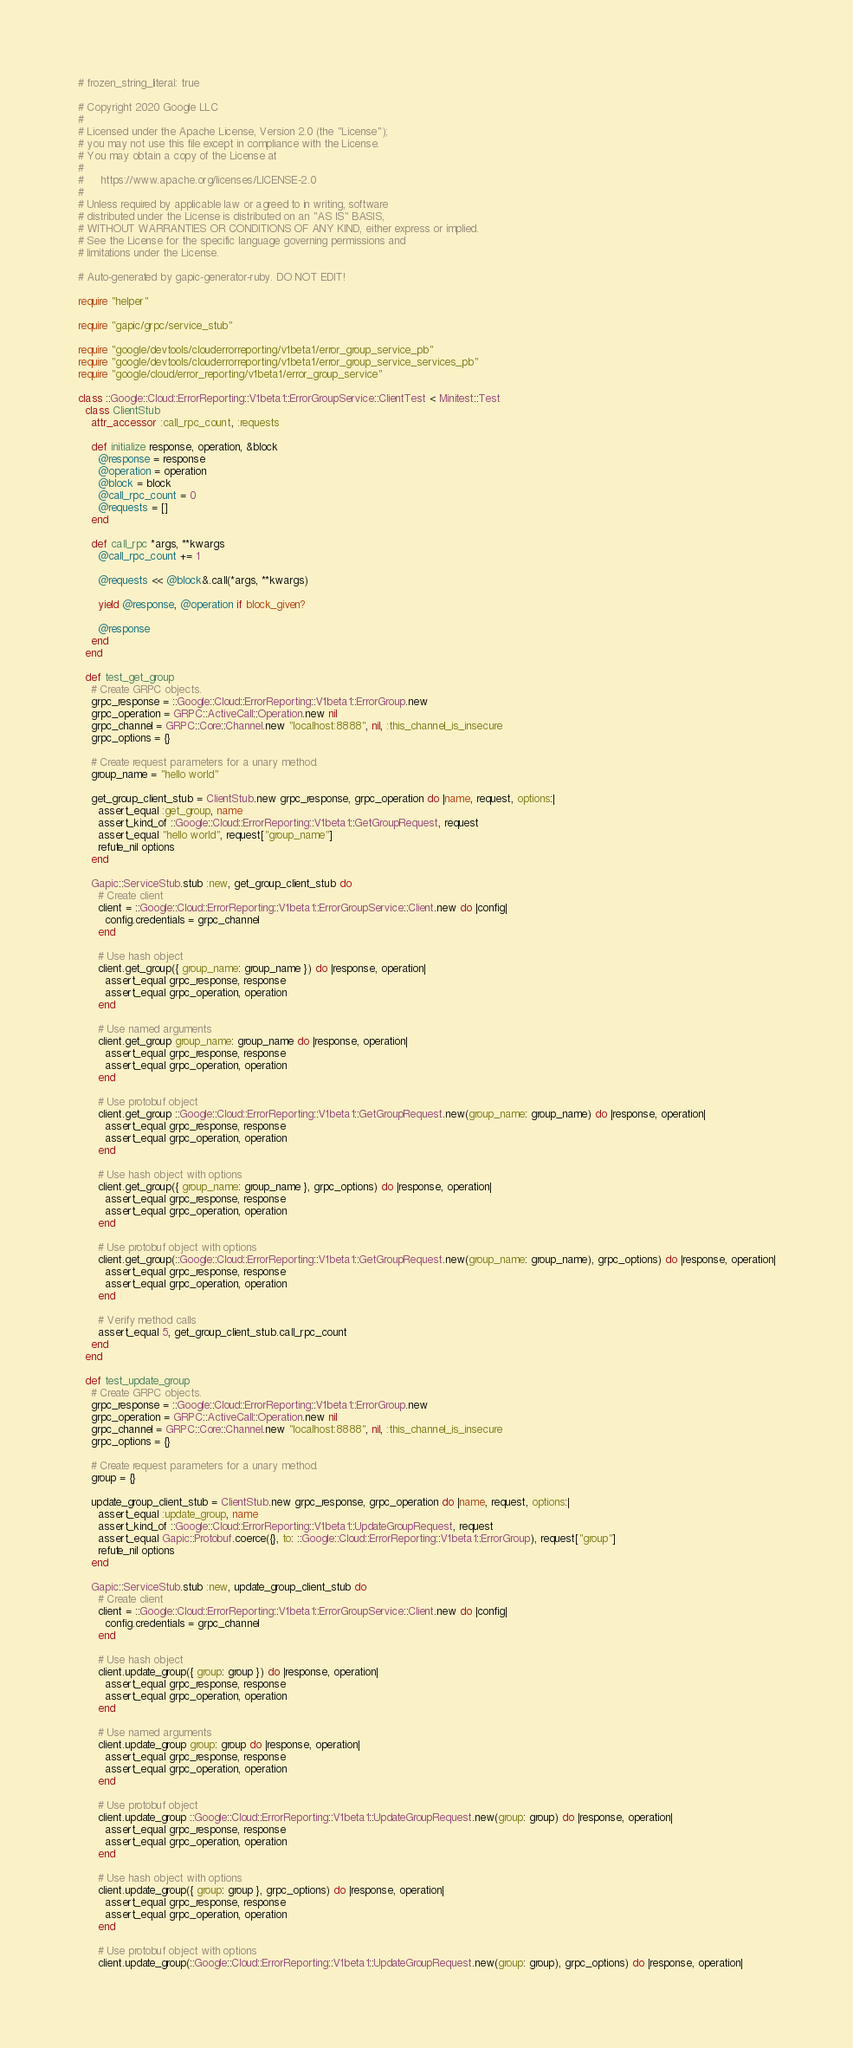<code> <loc_0><loc_0><loc_500><loc_500><_Ruby_># frozen_string_literal: true

# Copyright 2020 Google LLC
#
# Licensed under the Apache License, Version 2.0 (the "License");
# you may not use this file except in compliance with the License.
# You may obtain a copy of the License at
#
#     https://www.apache.org/licenses/LICENSE-2.0
#
# Unless required by applicable law or agreed to in writing, software
# distributed under the License is distributed on an "AS IS" BASIS,
# WITHOUT WARRANTIES OR CONDITIONS OF ANY KIND, either express or implied.
# See the License for the specific language governing permissions and
# limitations under the License.

# Auto-generated by gapic-generator-ruby. DO NOT EDIT!

require "helper"

require "gapic/grpc/service_stub"

require "google/devtools/clouderrorreporting/v1beta1/error_group_service_pb"
require "google/devtools/clouderrorreporting/v1beta1/error_group_service_services_pb"
require "google/cloud/error_reporting/v1beta1/error_group_service"

class ::Google::Cloud::ErrorReporting::V1beta1::ErrorGroupService::ClientTest < Minitest::Test
  class ClientStub
    attr_accessor :call_rpc_count, :requests

    def initialize response, operation, &block
      @response = response
      @operation = operation
      @block = block
      @call_rpc_count = 0
      @requests = []
    end

    def call_rpc *args, **kwargs
      @call_rpc_count += 1

      @requests << @block&.call(*args, **kwargs)

      yield @response, @operation if block_given?

      @response
    end
  end

  def test_get_group
    # Create GRPC objects.
    grpc_response = ::Google::Cloud::ErrorReporting::V1beta1::ErrorGroup.new
    grpc_operation = GRPC::ActiveCall::Operation.new nil
    grpc_channel = GRPC::Core::Channel.new "localhost:8888", nil, :this_channel_is_insecure
    grpc_options = {}

    # Create request parameters for a unary method.
    group_name = "hello world"

    get_group_client_stub = ClientStub.new grpc_response, grpc_operation do |name, request, options:|
      assert_equal :get_group, name
      assert_kind_of ::Google::Cloud::ErrorReporting::V1beta1::GetGroupRequest, request
      assert_equal "hello world", request["group_name"]
      refute_nil options
    end

    Gapic::ServiceStub.stub :new, get_group_client_stub do
      # Create client
      client = ::Google::Cloud::ErrorReporting::V1beta1::ErrorGroupService::Client.new do |config|
        config.credentials = grpc_channel
      end

      # Use hash object
      client.get_group({ group_name: group_name }) do |response, operation|
        assert_equal grpc_response, response
        assert_equal grpc_operation, operation
      end

      # Use named arguments
      client.get_group group_name: group_name do |response, operation|
        assert_equal grpc_response, response
        assert_equal grpc_operation, operation
      end

      # Use protobuf object
      client.get_group ::Google::Cloud::ErrorReporting::V1beta1::GetGroupRequest.new(group_name: group_name) do |response, operation|
        assert_equal grpc_response, response
        assert_equal grpc_operation, operation
      end

      # Use hash object with options
      client.get_group({ group_name: group_name }, grpc_options) do |response, operation|
        assert_equal grpc_response, response
        assert_equal grpc_operation, operation
      end

      # Use protobuf object with options
      client.get_group(::Google::Cloud::ErrorReporting::V1beta1::GetGroupRequest.new(group_name: group_name), grpc_options) do |response, operation|
        assert_equal grpc_response, response
        assert_equal grpc_operation, operation
      end

      # Verify method calls
      assert_equal 5, get_group_client_stub.call_rpc_count
    end
  end

  def test_update_group
    # Create GRPC objects.
    grpc_response = ::Google::Cloud::ErrorReporting::V1beta1::ErrorGroup.new
    grpc_operation = GRPC::ActiveCall::Operation.new nil
    grpc_channel = GRPC::Core::Channel.new "localhost:8888", nil, :this_channel_is_insecure
    grpc_options = {}

    # Create request parameters for a unary method.
    group = {}

    update_group_client_stub = ClientStub.new grpc_response, grpc_operation do |name, request, options:|
      assert_equal :update_group, name
      assert_kind_of ::Google::Cloud::ErrorReporting::V1beta1::UpdateGroupRequest, request
      assert_equal Gapic::Protobuf.coerce({}, to: ::Google::Cloud::ErrorReporting::V1beta1::ErrorGroup), request["group"]
      refute_nil options
    end

    Gapic::ServiceStub.stub :new, update_group_client_stub do
      # Create client
      client = ::Google::Cloud::ErrorReporting::V1beta1::ErrorGroupService::Client.new do |config|
        config.credentials = grpc_channel
      end

      # Use hash object
      client.update_group({ group: group }) do |response, operation|
        assert_equal grpc_response, response
        assert_equal grpc_operation, operation
      end

      # Use named arguments
      client.update_group group: group do |response, operation|
        assert_equal grpc_response, response
        assert_equal grpc_operation, operation
      end

      # Use protobuf object
      client.update_group ::Google::Cloud::ErrorReporting::V1beta1::UpdateGroupRequest.new(group: group) do |response, operation|
        assert_equal grpc_response, response
        assert_equal grpc_operation, operation
      end

      # Use hash object with options
      client.update_group({ group: group }, grpc_options) do |response, operation|
        assert_equal grpc_response, response
        assert_equal grpc_operation, operation
      end

      # Use protobuf object with options
      client.update_group(::Google::Cloud::ErrorReporting::V1beta1::UpdateGroupRequest.new(group: group), grpc_options) do |response, operation|</code> 